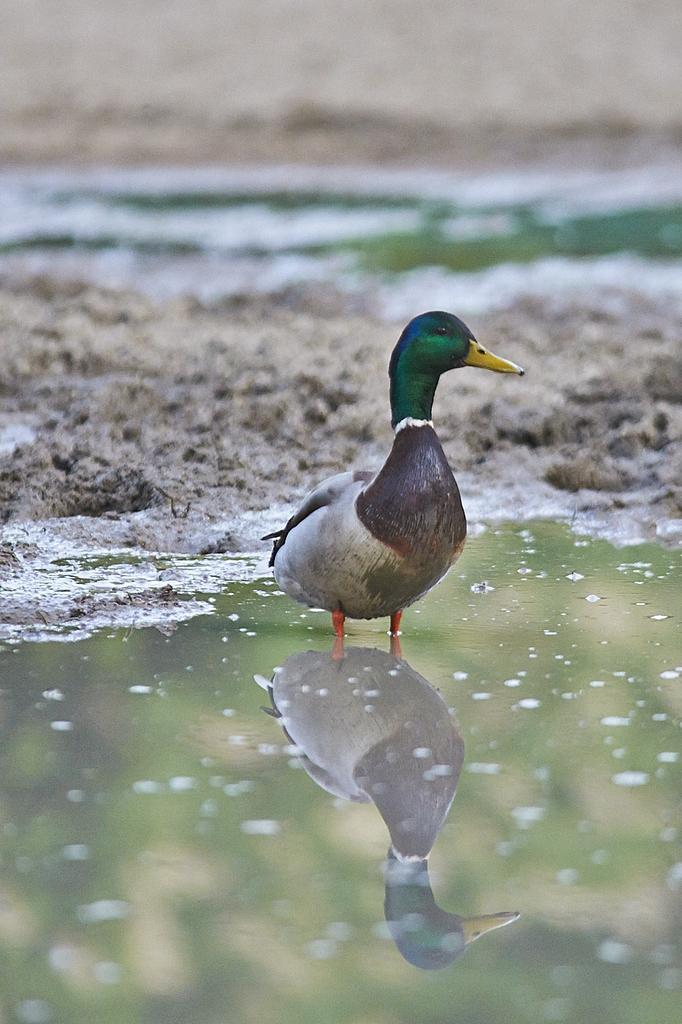What type of animal is in the image? There is a duck in the image. What color is the duck's head? The duck's head is green. What color is the duck's body? The duck's body is grey. What is at the bottom of the image? There is water at the bottom of the image. What type of quartz can be seen in the image? There is no quartz present in the image. What action is the girl performing in the image? There is no girl present in the image, so no action can be attributed to her. 